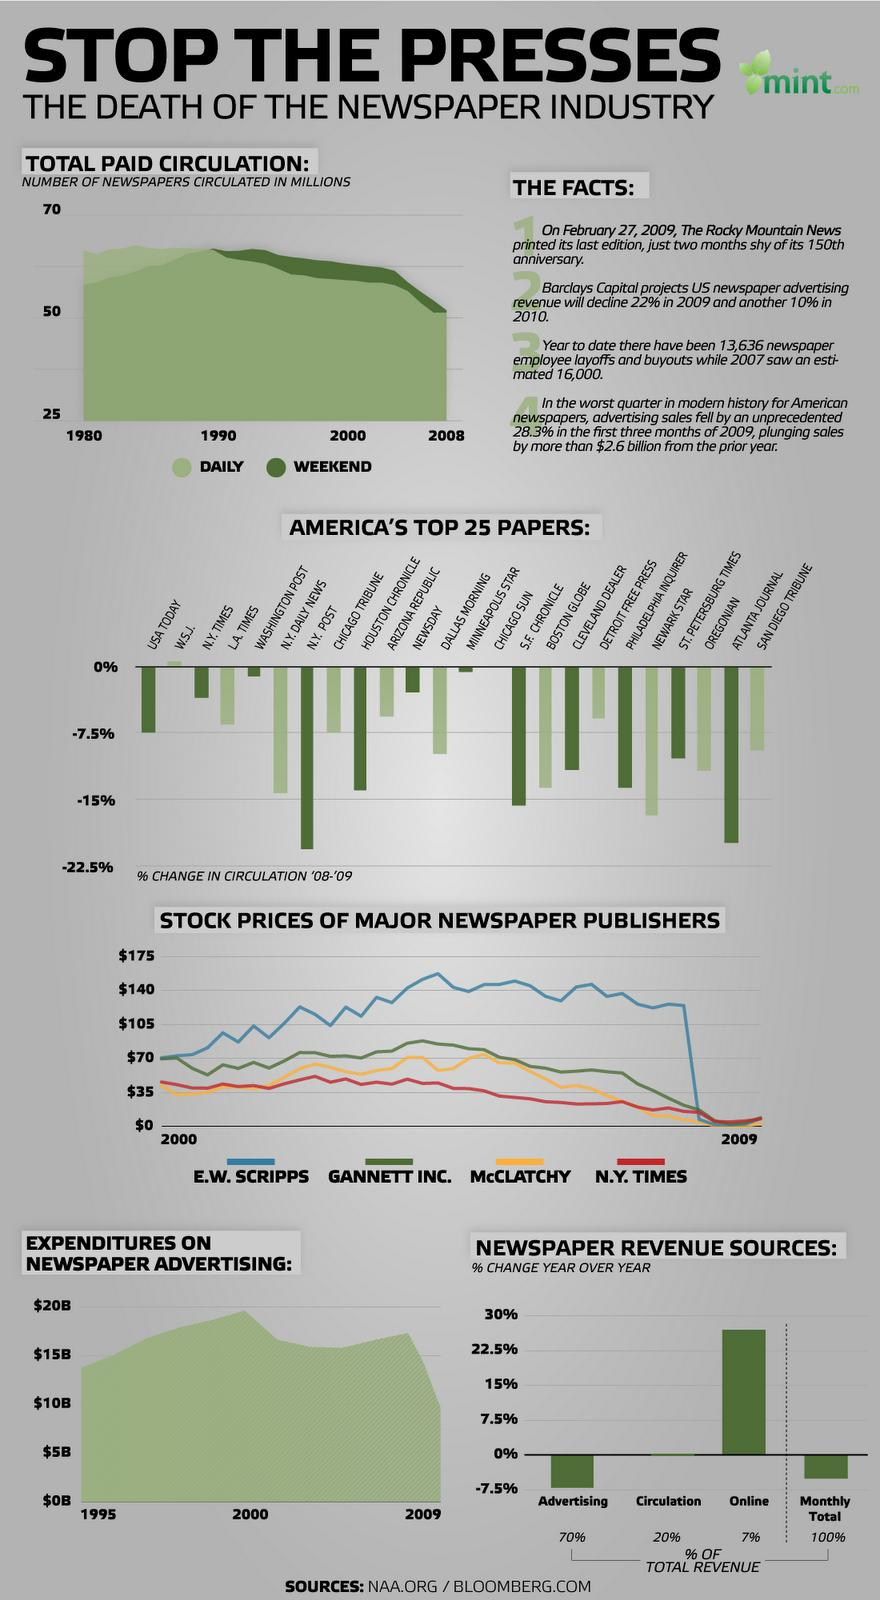Indicate a few pertinent items in this graphic. Approximately 27% of a newspaper's revenue is derived from both online and circulation sources. Approximately 90% of a newspaper's revenue is derived from advertising and circulation combined. 